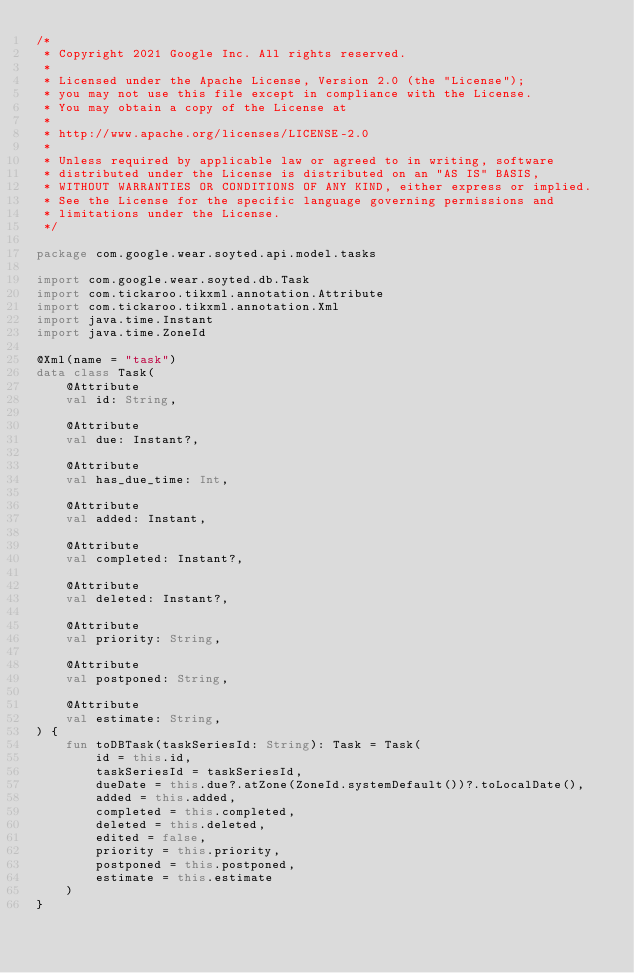<code> <loc_0><loc_0><loc_500><loc_500><_Kotlin_>/*
 * Copyright 2021 Google Inc. All rights reserved.
 *
 * Licensed under the Apache License, Version 2.0 (the "License");
 * you may not use this file except in compliance with the License.
 * You may obtain a copy of the License at
 *
 * http://www.apache.org/licenses/LICENSE-2.0
 *
 * Unless required by applicable law or agreed to in writing, software
 * distributed under the License is distributed on an "AS IS" BASIS,
 * WITHOUT WARRANTIES OR CONDITIONS OF ANY KIND, either express or implied.
 * See the License for the specific language governing permissions and
 * limitations under the License.
 */

package com.google.wear.soyted.api.model.tasks

import com.google.wear.soyted.db.Task
import com.tickaroo.tikxml.annotation.Attribute
import com.tickaroo.tikxml.annotation.Xml
import java.time.Instant
import java.time.ZoneId

@Xml(name = "task")
data class Task(
    @Attribute
    val id: String,

    @Attribute
    val due: Instant?,

    @Attribute
    val has_due_time: Int,

    @Attribute
    val added: Instant,

    @Attribute
    val completed: Instant?,

    @Attribute
    val deleted: Instant?,

    @Attribute
    val priority: String,

    @Attribute
    val postponed: String,

    @Attribute
    val estimate: String,
) {
    fun toDBTask(taskSeriesId: String): Task = Task(
        id = this.id,
        taskSeriesId = taskSeriesId,
        dueDate = this.due?.atZone(ZoneId.systemDefault())?.toLocalDate(),
        added = this.added,
        completed = this.completed,
        deleted = this.deleted,
        edited = false,
        priority = this.priority,
        postponed = this.postponed,
        estimate = this.estimate
    )
}
</code> 